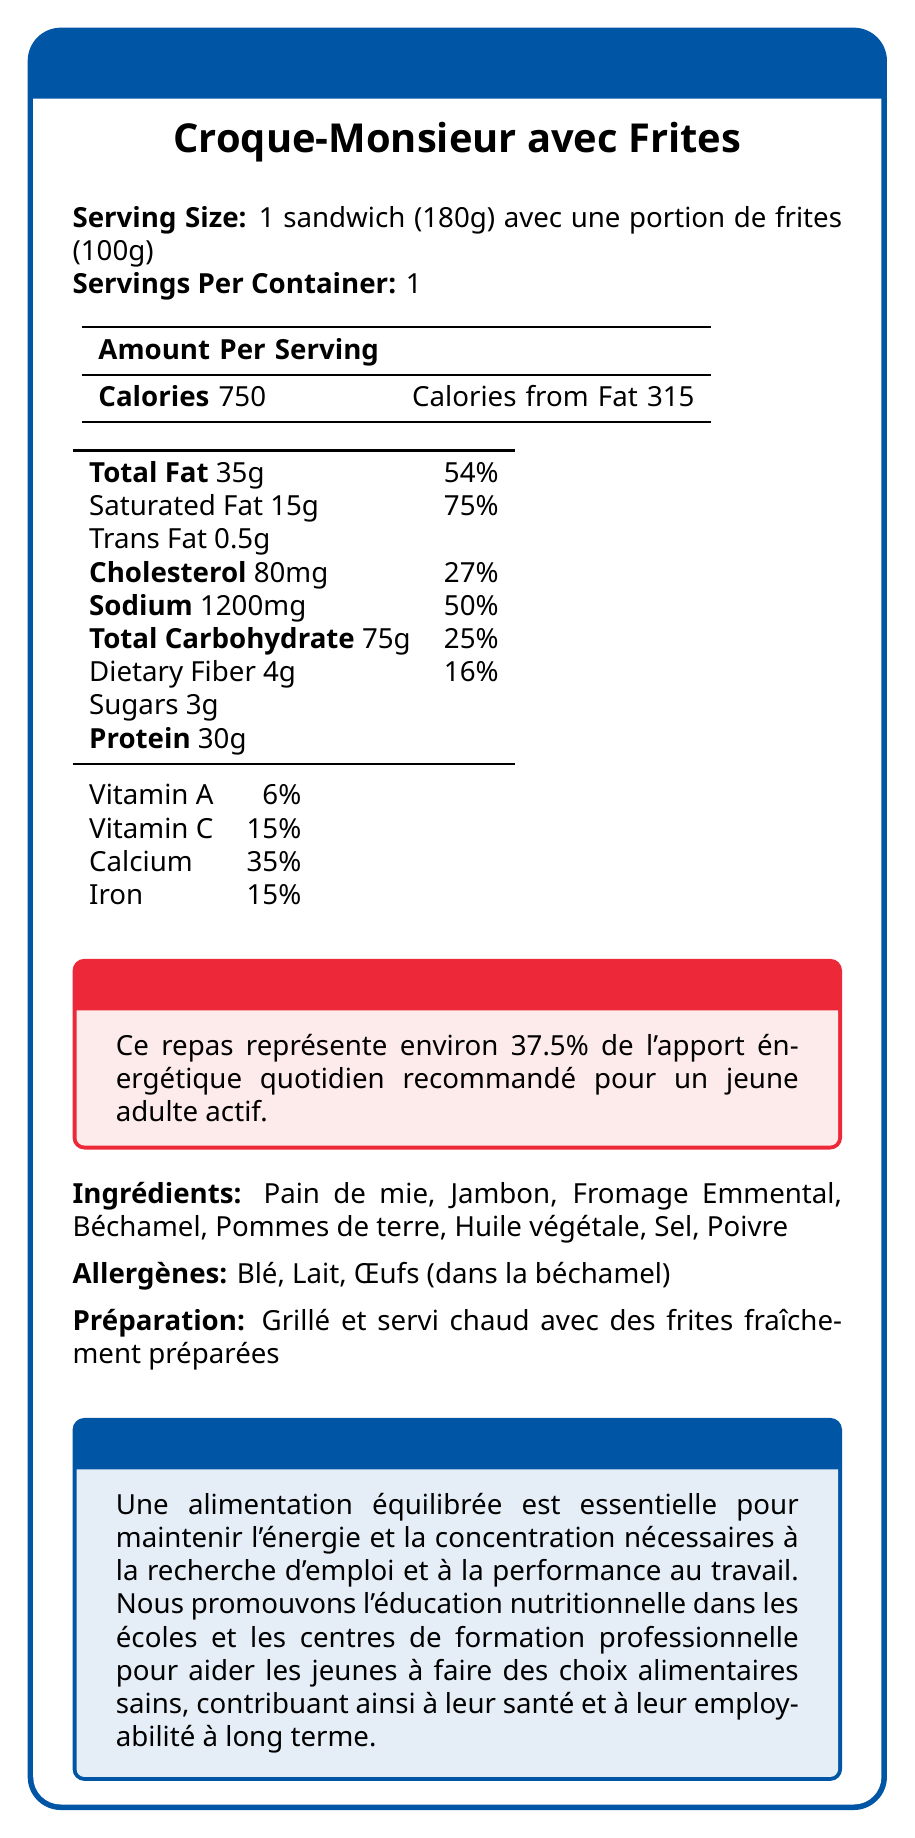What is the serving size for the Croque-Monsieur avec Frites? The serving size is clearly indicated as 1 sandwich (180g) along with a portion of fries (100g).
Answer: 1 sandwich (180g) avec une portion de frites (100g) How many calories are in one serving of this meal? The document lists the total calorie count as 750 calories per serving.
Answer: 750 calories What percentage of the recommended daily energy intake for an active young adult does this meal represent? A highlighted section in the document states that this meal represents approximately 37.5% of the recommended daily energy intake for an active young adult.
Answer: 37.5% How much protein does one serving contain? The amount of protein per serving is listed as 30 grams in the nutritional information table.
Answer: 30 grams Name three allergens present in this meal. The listed allergens in the document are wheat (Blé), milk (Lait), and eggs (Œufs).
Answer: Blé, Lait, Œufs What is the total fat content per serving? A. 25g B. 35g C. 45g D. 55g The document lists the total fat content per serving as 35 grams.
Answer: B. 35g What is the preparation method for this meal? A. Boiled B. Grilled C. Baked D. Fried The preparation method is described as "Grillé et servi chaud avec des frites fraîchement préparées" (Grilled and served hot with freshly prepared fries).
Answer: B. Grilled Does this meal contain trans fat? The document lists that the meal contains 0.5 grams of trans fat.
Answer: Yes Can the document confirm if this meal is suitable for someone with a nut allergy? The document does not provide any information about the presence or absence of nuts or nut-derived ingredients.
Answer: Not enough information Summarize the main focus of the nutrition facts label for "Croque-Monsieur avec Frites". The document provides a comprehensive breakdown of the nutritional value of the meal, including calories, fats, proteins, and key vitamins and minerals. It also includes sections highlighting the implications for energy intake and overall health, which are particularly important for young adults.
Answer: The nutrition facts label provides detailed nutritional information for a single serving of "Croque-Monsieur avec Frites," which consists of 1 sandwich and a portion of fries. It includes the calorie content, fat, cholesterol, sodium, carbohydrate, fiber, sugars, and protein content. It also lists vitamins and minerals, allergens, and preparation method. A focused section highlights that the meal represents about 37.5% of the daily energy intake for an active young adult, emphasizing the necessity of balanced nutrition for maintaining energy and concentration, especially relevant for young people seeking employment. 